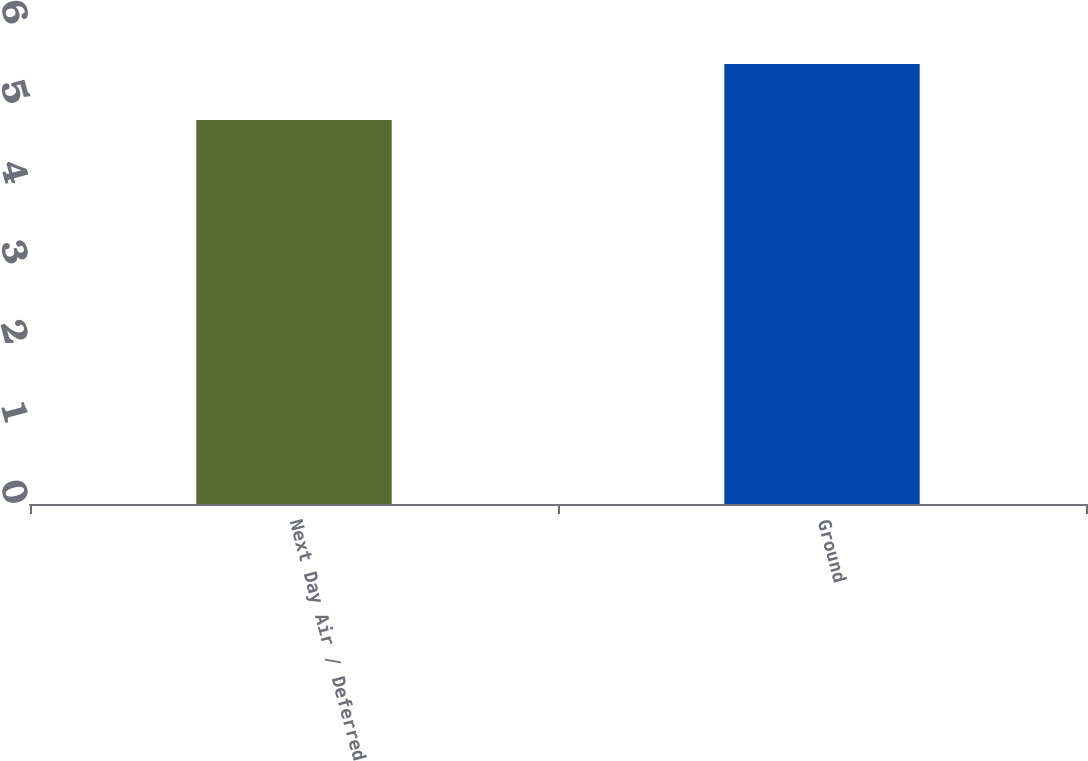Convert chart to OTSL. <chart><loc_0><loc_0><loc_500><loc_500><bar_chart><fcel>Next Day Air / Deferred<fcel>Ground<nl><fcel>4.8<fcel>5.5<nl></chart> 